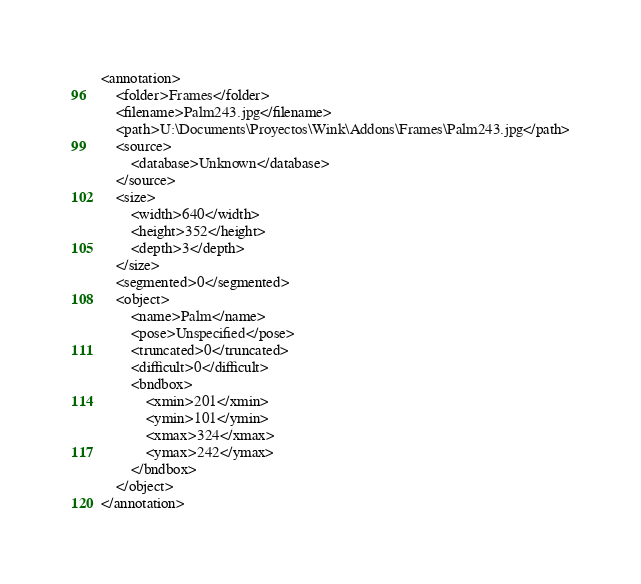<code> <loc_0><loc_0><loc_500><loc_500><_XML_><annotation>
	<folder>Frames</folder>
	<filename>Palm243.jpg</filename>
	<path>U:\Documents\Proyectos\Wink\Addons\Frames\Palm243.jpg</path>
	<source>
		<database>Unknown</database>
	</source>
	<size>
		<width>640</width>
		<height>352</height>
		<depth>3</depth>
	</size>
	<segmented>0</segmented>
	<object>
		<name>Palm</name>
		<pose>Unspecified</pose>
		<truncated>0</truncated>
		<difficult>0</difficult>
		<bndbox>
			<xmin>201</xmin>
			<ymin>101</ymin>
			<xmax>324</xmax>
			<ymax>242</ymax>
		</bndbox>
	</object>
</annotation>
</code> 